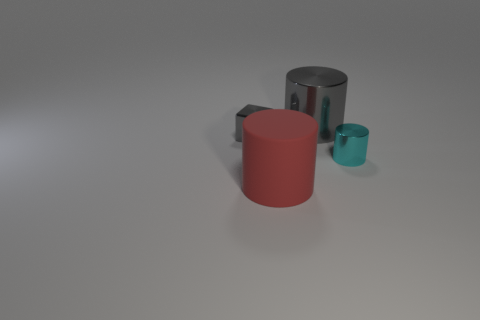Is there anything else that has the same material as the large red object?
Provide a succinct answer. No. Do the red rubber thing and the gray metallic cylinder have the same size?
Your answer should be compact. Yes. What is the shape of the thing that is both on the left side of the big gray shiny thing and behind the big rubber thing?
Keep it short and to the point. Cube. What number of large yellow blocks are the same material as the small gray block?
Offer a very short reply. 0. There is a tiny metal object that is to the left of the large metal object; how many gray shiny cubes are behind it?
Make the answer very short. 0. There is a big object behind the gray metallic thing in front of the big cylinder behind the tiny block; what shape is it?
Your response must be concise. Cylinder. What size is the metal object that is the same color as the block?
Give a very brief answer. Large. How many objects are either tiny gray metallic blocks or big metallic objects?
Keep it short and to the point. 2. What color is the thing that is the same size as the rubber cylinder?
Your response must be concise. Gray. There is a red matte thing; is it the same shape as the tiny shiny thing that is to the right of the gray metallic cube?
Make the answer very short. Yes. 